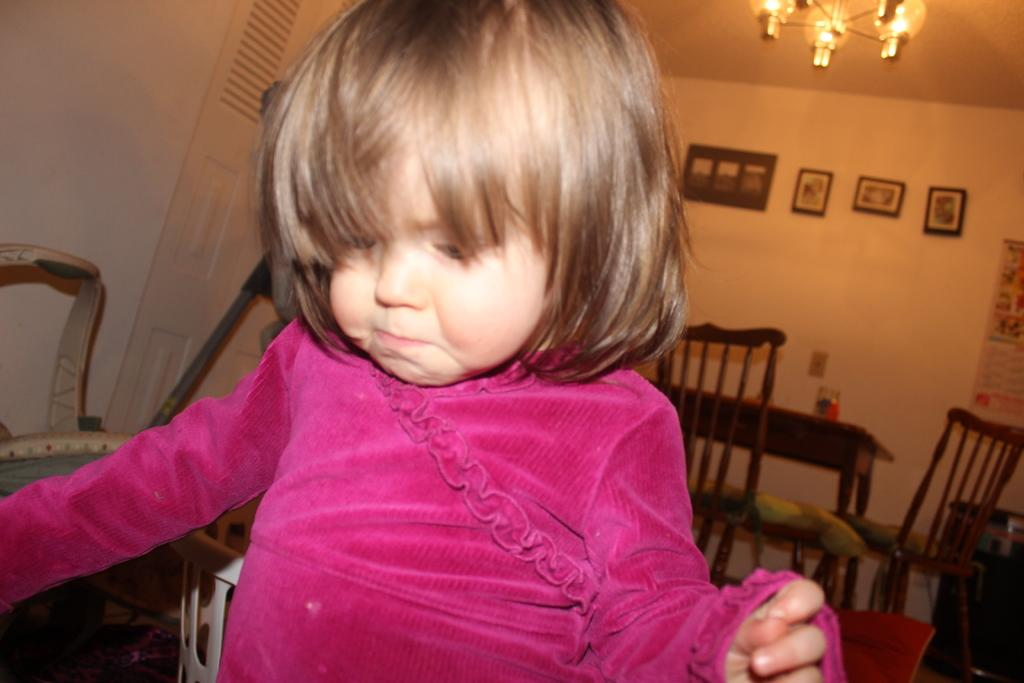What is the main subject of the picture? The main subject of the picture is a kid. What is the kid wearing? The kid is wearing a pink dress. What can be seen on the wall in the image? There are different types of pictures on the wall. What is the source of light in the image? There is a light on top in the image. What type of furniture is visible in the image? Chairs and a table are visible in the image. What type of fruit is being served on the table in the image? There is no fruit visible on the table in the image. What kind of haircut does the kid have in the image? The image does not show the kid's haircut, as it focuses on the kid's clothing and the surrounding environment. 